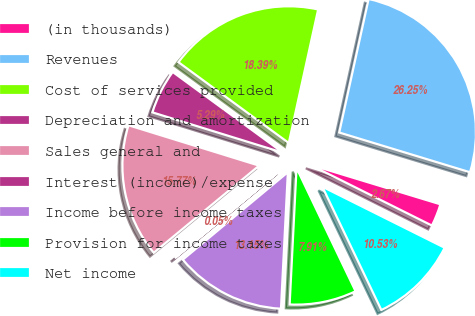Convert chart. <chart><loc_0><loc_0><loc_500><loc_500><pie_chart><fcel>(in thousands)<fcel>Revenues<fcel>Cost of services provided<fcel>Depreciation and amortization<fcel>Sales general and<fcel>Interest (income)/expense<fcel>Income before income taxes<fcel>Provision for income taxes<fcel>Net income<nl><fcel>2.67%<fcel>26.25%<fcel>18.39%<fcel>5.29%<fcel>15.77%<fcel>0.05%<fcel>13.15%<fcel>7.91%<fcel>10.53%<nl></chart> 